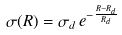Convert formula to latex. <formula><loc_0><loc_0><loc_500><loc_500>\sigma ( R ) = \sigma _ { d } \, e ^ { - \frac { R - R _ { d } } { R _ { d } } }</formula> 